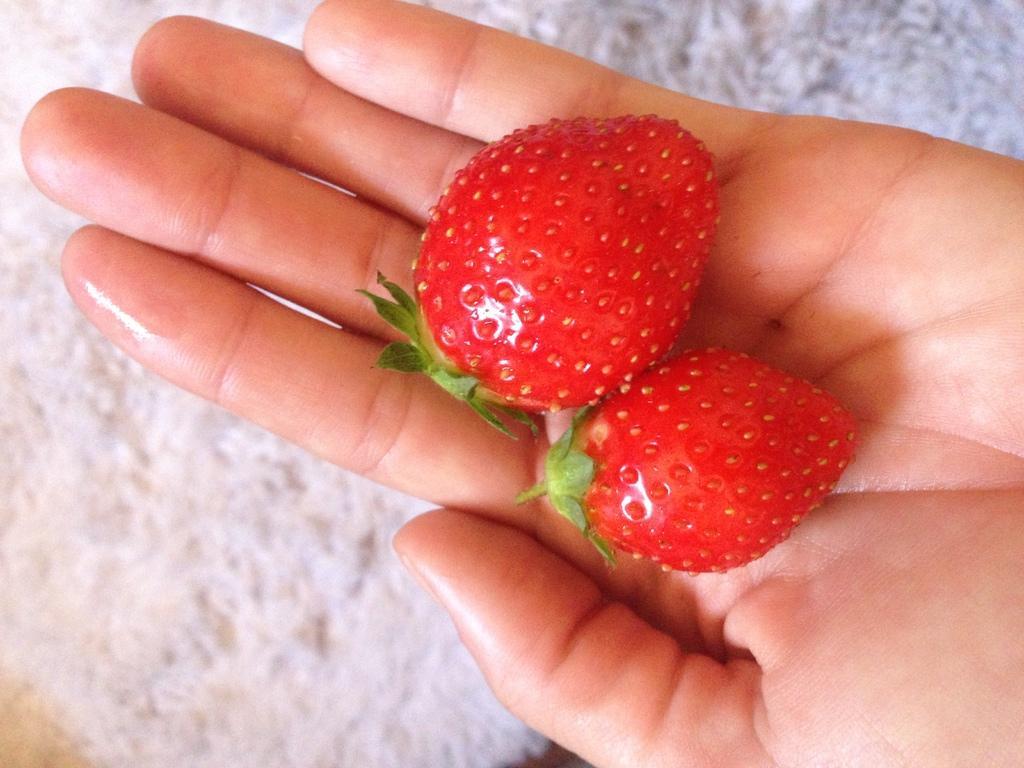Could you give a brief overview of what you see in this image? We can see strawberries on person hand. Under the hand we can see white object. 